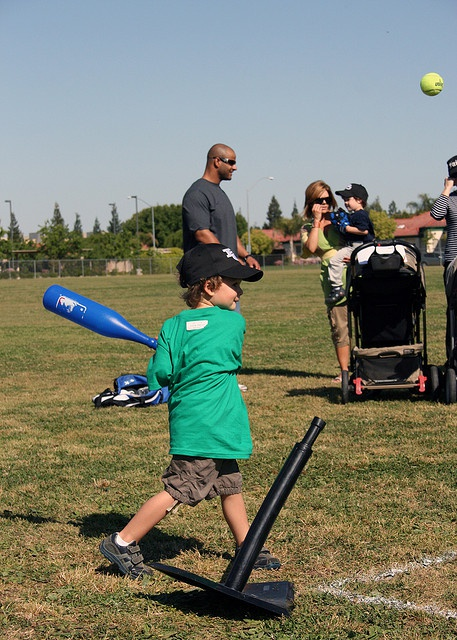Describe the objects in this image and their specific colors. I can see people in darkgray, black, turquoise, and teal tones, people in darkgray, gray, black, brown, and maroon tones, people in darkgray, black, gray, and tan tones, people in darkgray, black, gray, and lightgray tones, and people in darkgray, black, lightgray, and tan tones in this image. 